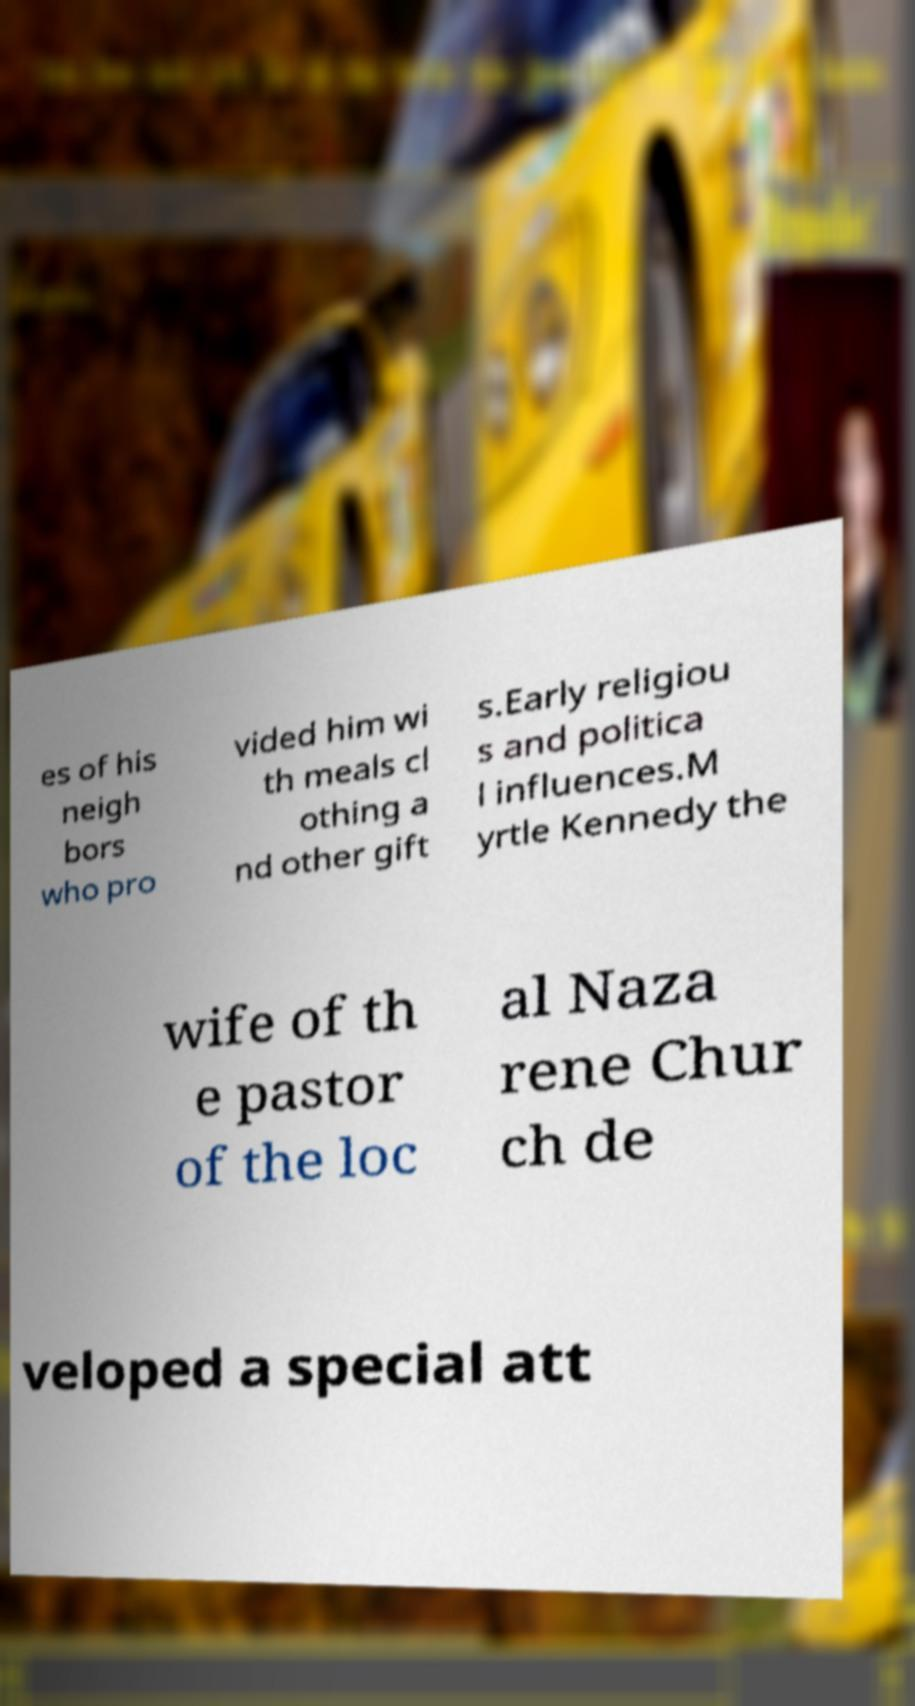Can you accurately transcribe the text from the provided image for me? es of his neigh bors who pro vided him wi th meals cl othing a nd other gift s.Early religiou s and politica l influences.M yrtle Kennedy the wife of th e pastor of the loc al Naza rene Chur ch de veloped a special att 